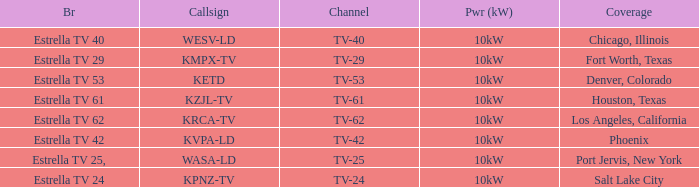Which area did estrella tv 62 provide coverage for? Los Angeles, California. 